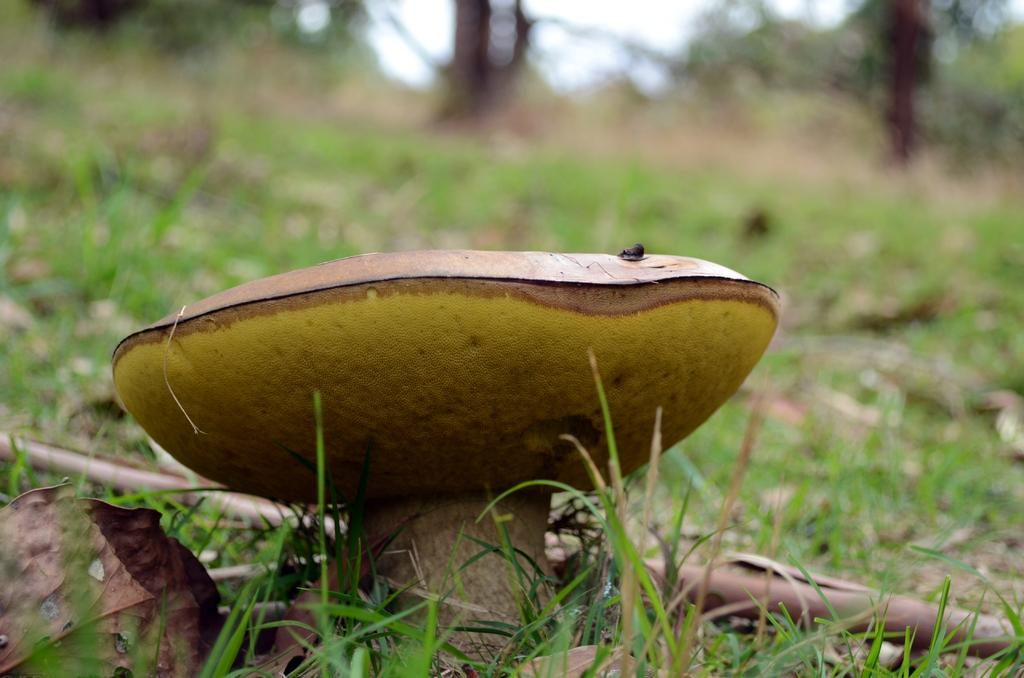What type of plant can be seen in the image? There is a mushroom in the image. What type of vegetation is present in the image besides the mushroom? There is grass visible in the image. What part of the natural environment is visible in the image? The sky is visible in the image. What type of hose can be seen in the image? There is no hose present in the image. What type of prose is written on the mushroom in the image? There is no prose or writing on the mushroom in the image. 